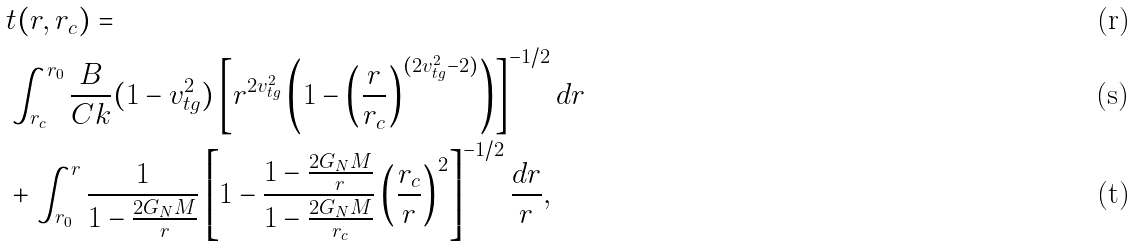<formula> <loc_0><loc_0><loc_500><loc_500>& t ( r , r _ { c } ) = \\ & \int _ { r _ { c } } ^ { r _ { 0 } } \frac { B } { C k } ( 1 - v _ { t g } ^ { 2 } ) \left [ r ^ { 2 v _ { t g } ^ { 2 } } \left ( 1 - \left ( \frac { r } { r _ { c } } \right ) ^ { ( 2 v _ { t g } ^ { 2 } - 2 ) } \right ) \right ] ^ { - 1 / 2 } d r \\ & + \int _ { r _ { 0 } } ^ { r } \frac { 1 } { 1 - \frac { 2 G _ { N } M } { r } } \left [ 1 - \frac { 1 - \frac { 2 G _ { N } M } { r } } { 1 - \frac { 2 G _ { N } M } { r _ { c } } } \left ( \frac { r _ { c } } { r } \right ) ^ { 2 } \right ] ^ { - 1 / 2 } \frac { d r } { r } ,</formula> 